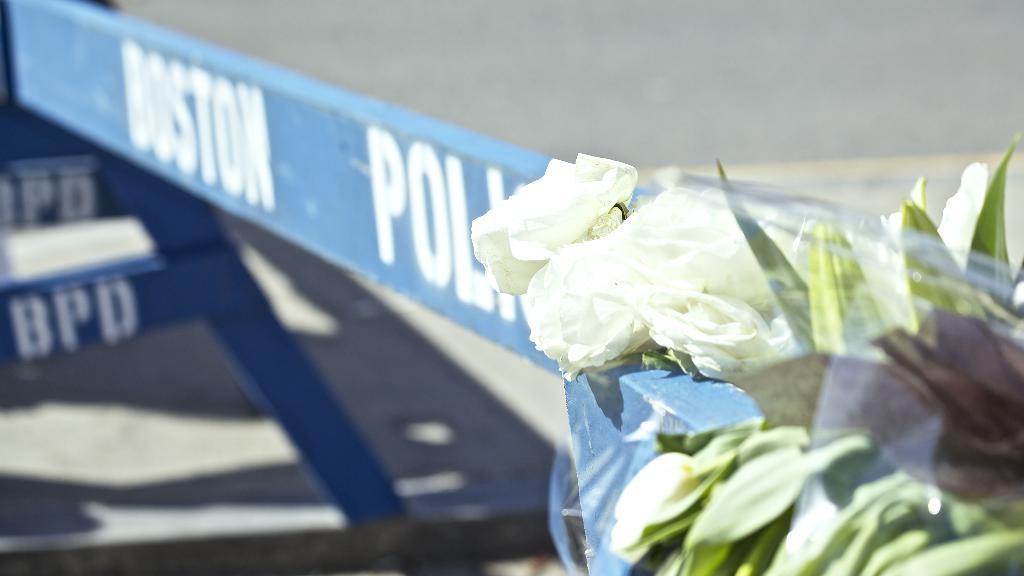How would you summarize this image in a sentence or two? In this image in the foreground there is a plant, and in the background there are some boards. And on the boards there is some text, and at the bottom there is a road. 